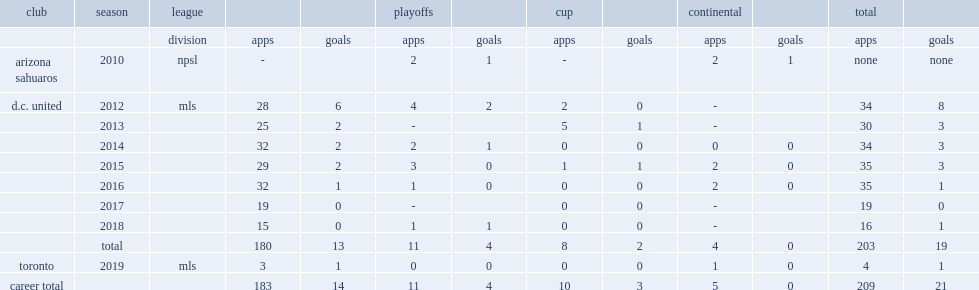Which club did deleon play for in 2010? Arizona sahuaros. 